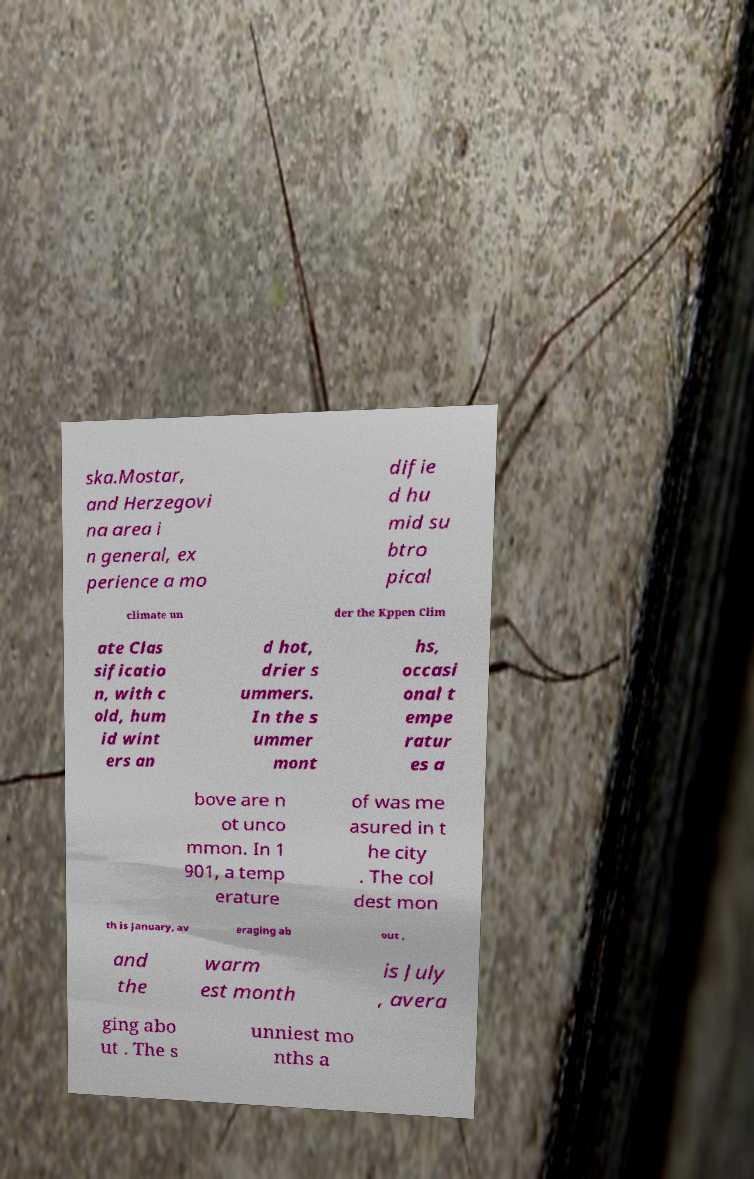Please read and relay the text visible in this image. What does it say? ska.Mostar, and Herzegovi na area i n general, ex perience a mo difie d hu mid su btro pical climate un der the Kppen Clim ate Clas sificatio n, with c old, hum id wint ers an d hot, drier s ummers. In the s ummer mont hs, occasi onal t empe ratur es a bove are n ot unco mmon. In 1 901, a temp erature of was me asured in t he city . The col dest mon th is January, av eraging ab out , and the warm est month is July , avera ging abo ut . The s unniest mo nths a 